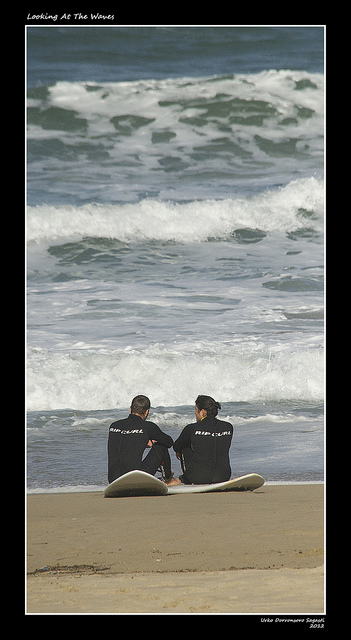What kind of equipment do the people have with them? The individuals are equipped with surfboards, which suggests they are preparing for or have finished surfing. Are the waves suitable for surfing right now? The waves appear to be of moderate size, indicating potentially suitable conditions for surfing, although this can be subjective and depend on the surfer's experience and preference. 